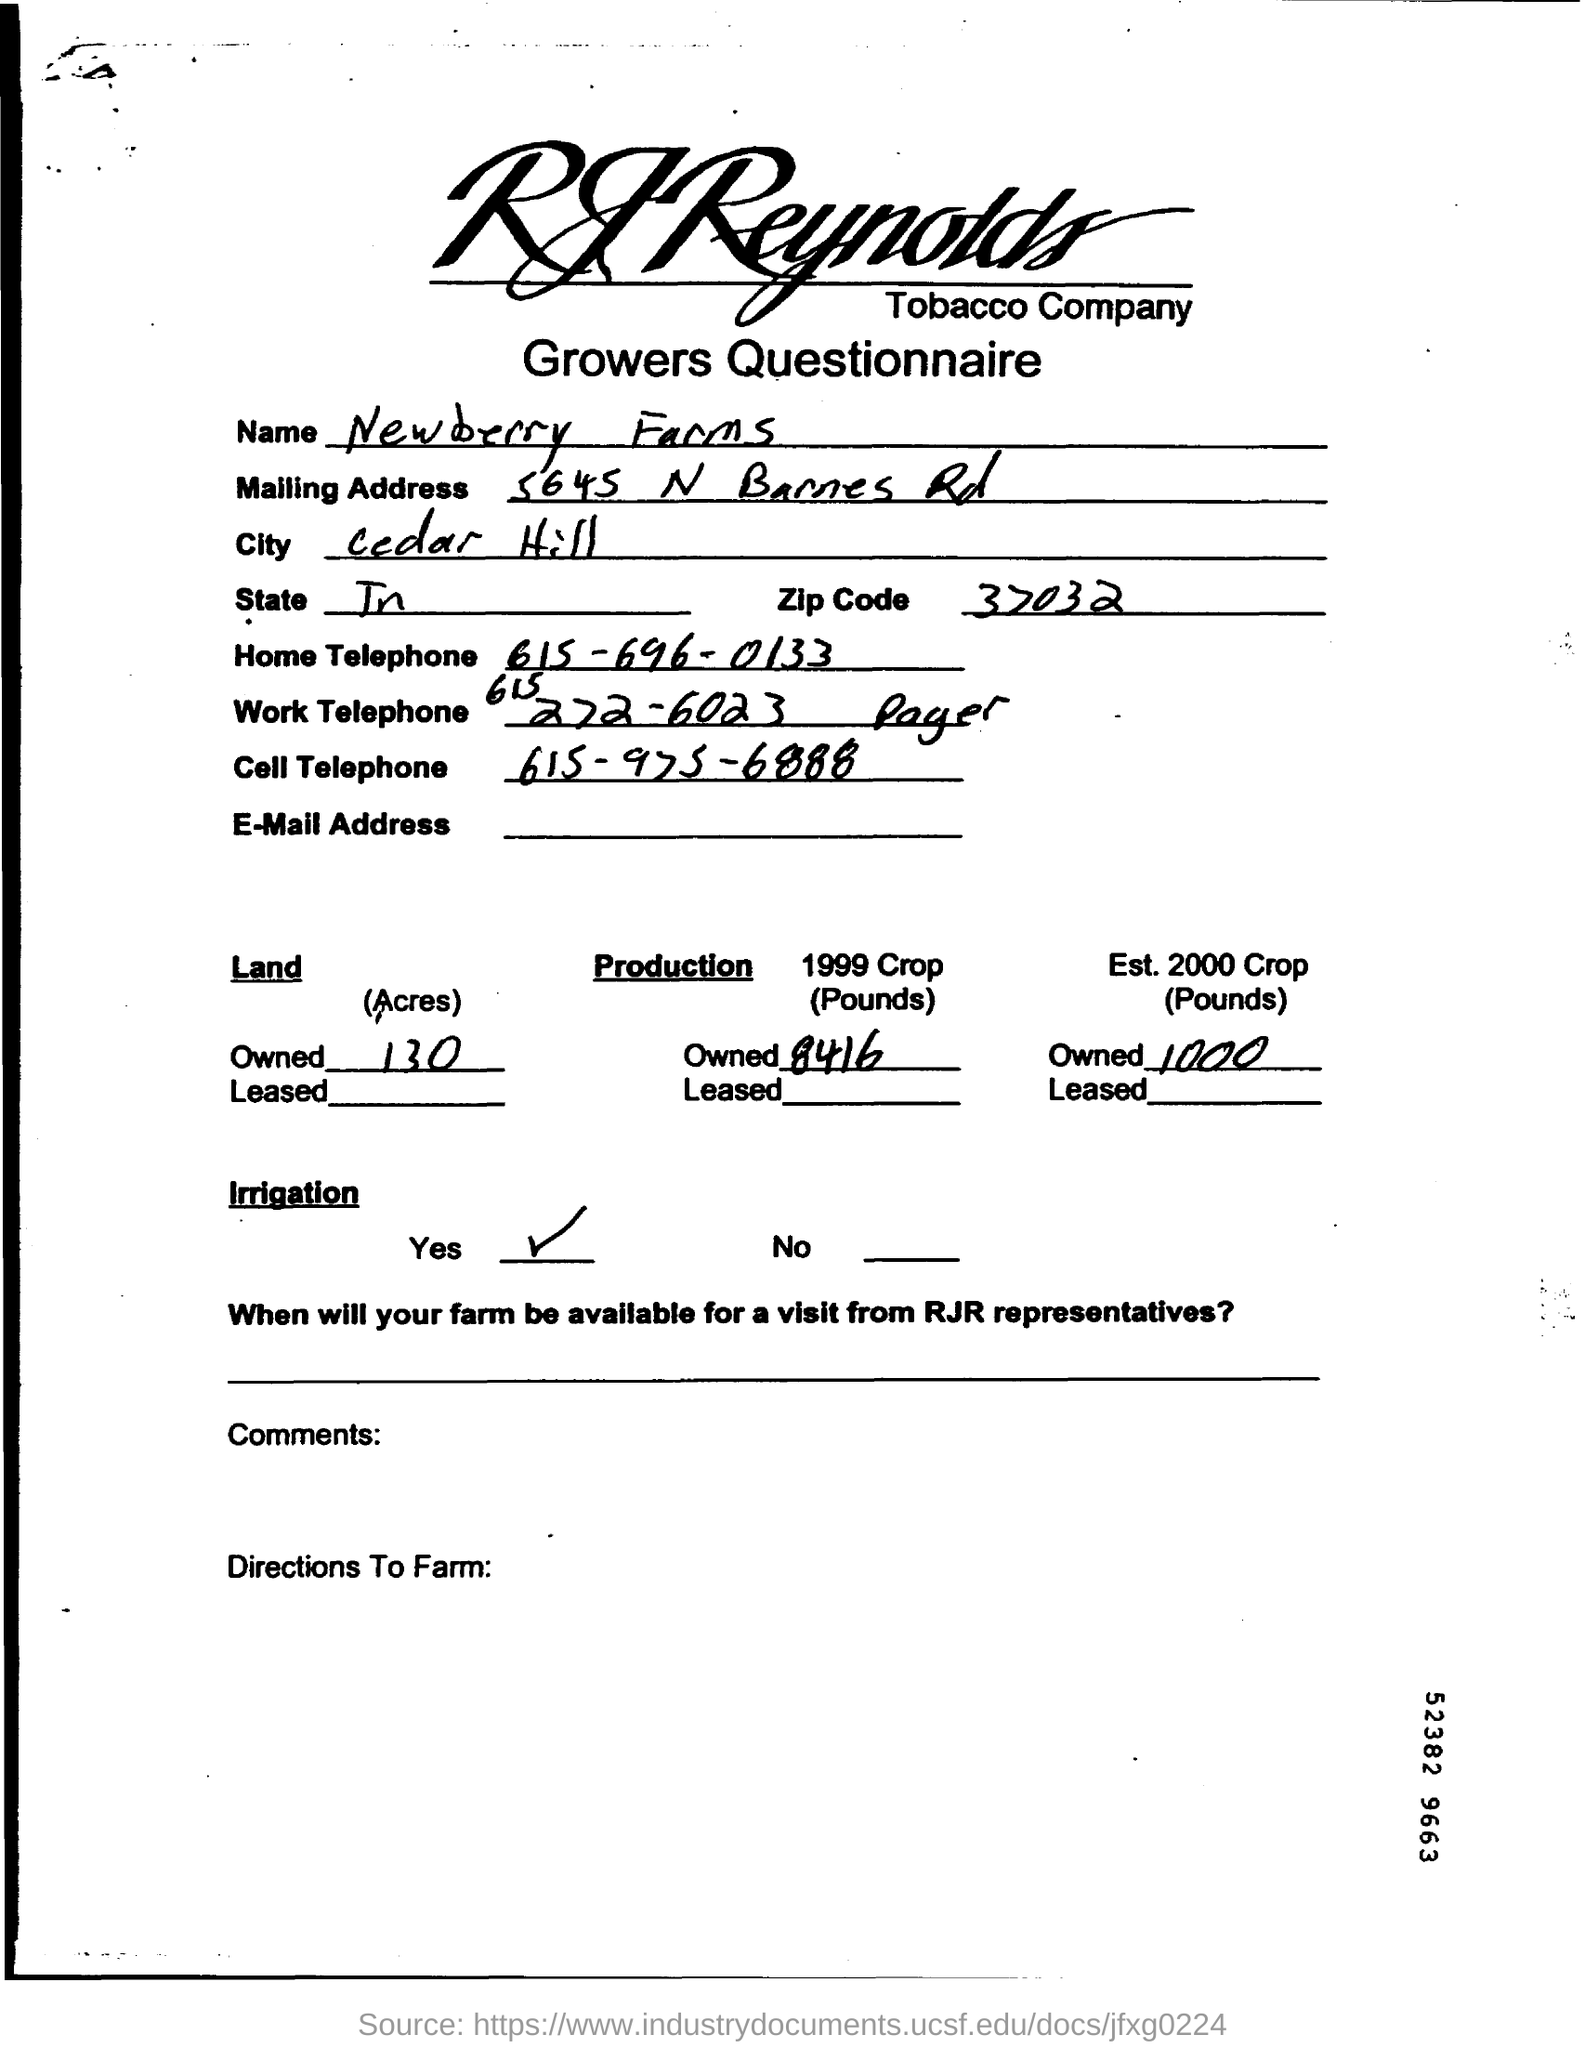What is the name?
Provide a short and direct response. Newberry Farms. What is the name of the city?
Keep it short and to the point. Cedar Hill. What is the zip code?
Keep it short and to the point. 37032. 